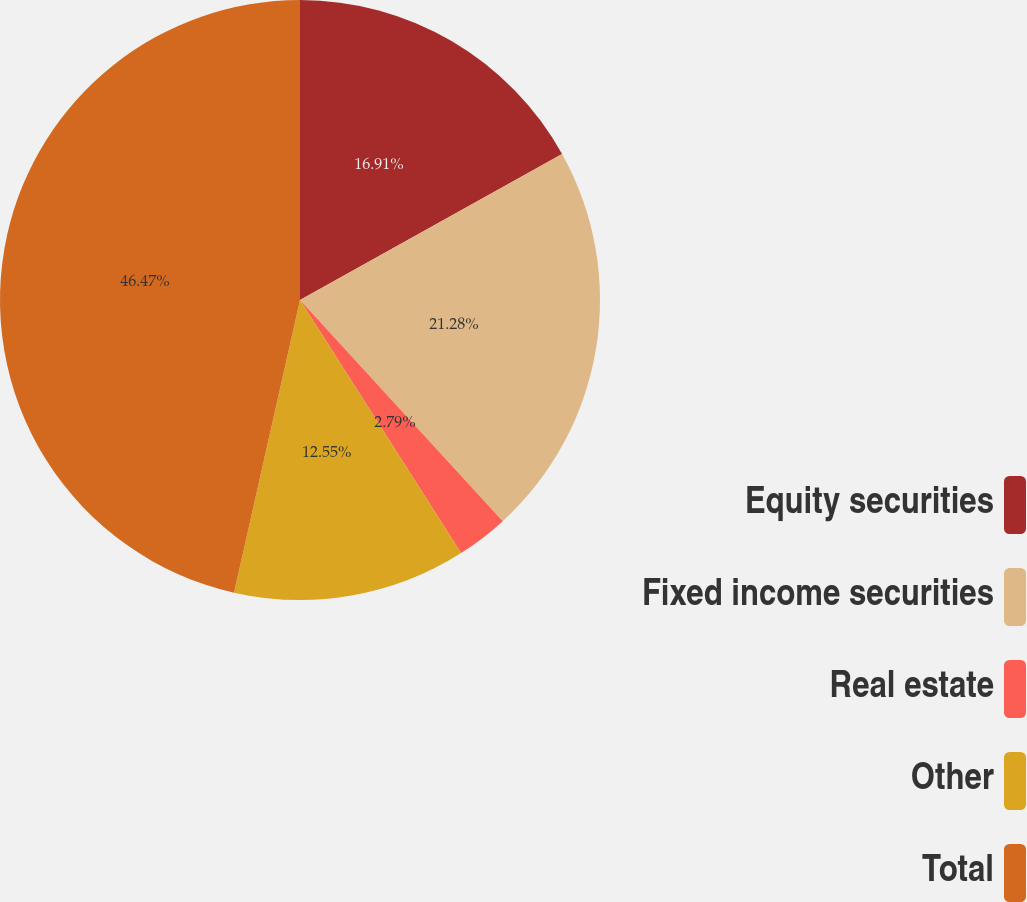Convert chart to OTSL. <chart><loc_0><loc_0><loc_500><loc_500><pie_chart><fcel>Equity securities<fcel>Fixed income securities<fcel>Real estate<fcel>Other<fcel>Total<nl><fcel>16.91%<fcel>21.28%<fcel>2.79%<fcel>12.55%<fcel>46.47%<nl></chart> 